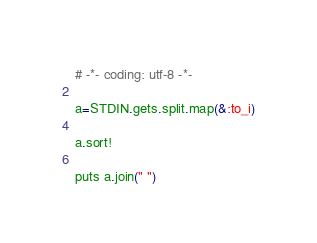<code> <loc_0><loc_0><loc_500><loc_500><_Ruby_># -*- coding: utf-8 -*-

a=STDIN.gets.split.map(&:to_i)

a.sort!

puts a.join(" ")</code> 